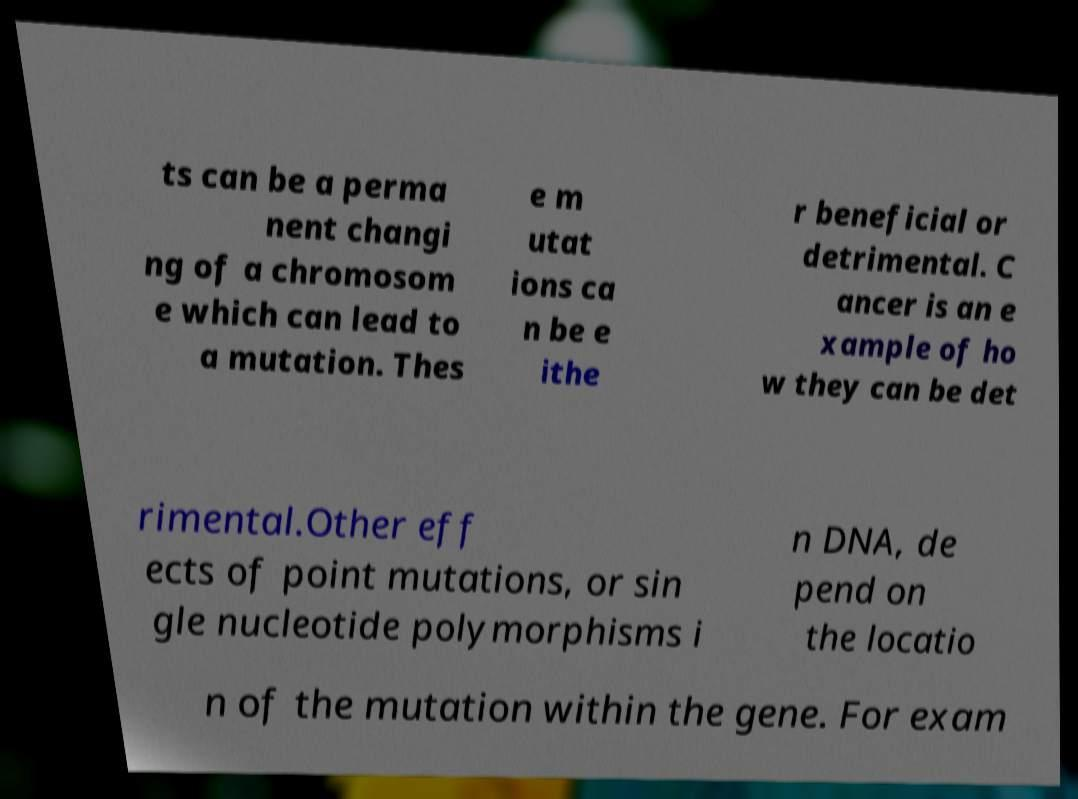Could you extract and type out the text from this image? ts can be a perma nent changi ng of a chromosom e which can lead to a mutation. Thes e m utat ions ca n be e ithe r beneficial or detrimental. C ancer is an e xample of ho w they can be det rimental.Other eff ects of point mutations, or sin gle nucleotide polymorphisms i n DNA, de pend on the locatio n of the mutation within the gene. For exam 